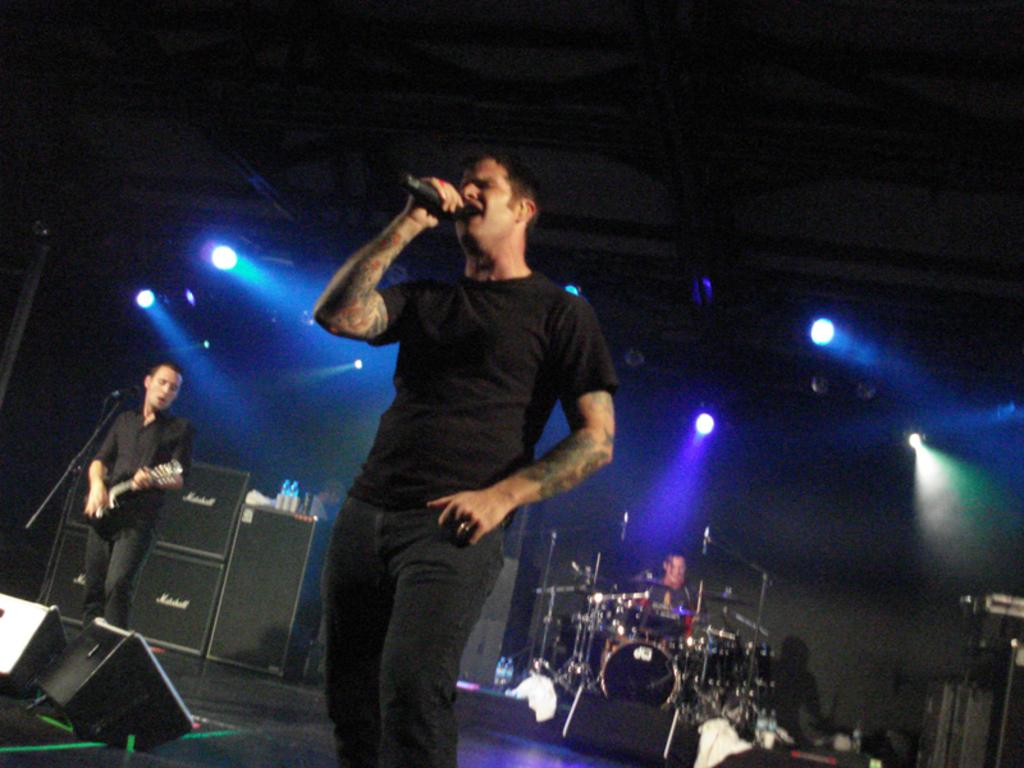What are the people on the stage doing? The people on the stage are singing and performing by playing musical instruments. What can be seen behind the people on the stage? There are lights behind the people on the stage. What type of key is being used by the person on the stage? There is no key visible in the image; the people on the stage are singing and playing musical instruments. What color is the hat worn by the person on the stage? There is no hat worn by any person on the stage in the image. 